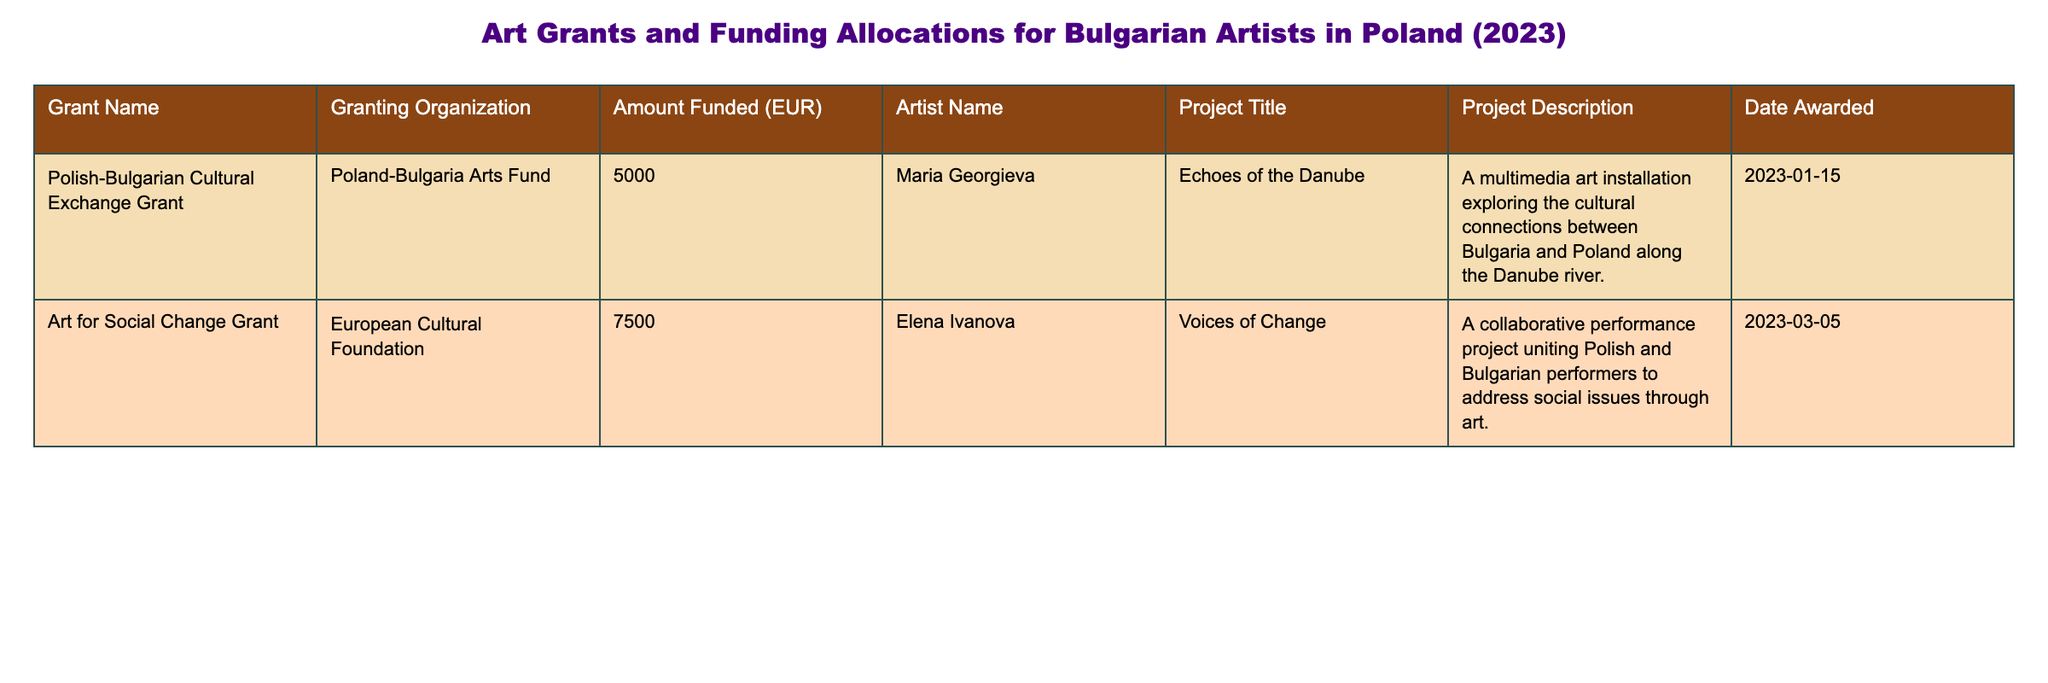What is the name of the grant awarded to Maria Georgieva? The table lists grants along with the names of the artists they were awarded to. According to the first row, the grant awarded to Maria Georgieva is the "Polish-Bulgarian Cultural Exchange Grant."
Answer: Polish-Bulgarian Cultural Exchange Grant How much funding was allocated to the project "Voices of Change"? In the second row of the table, the amount funded for the project "Voices of Change" is stated as 7500 EUR.
Answer: 7500 EUR Is there a grant supporting collaborative projects between Polish and Bulgarian artists? The table reveals information about various grants. The second row shows that the "Art for Social Change Grant" funds a collaborative performance project uniting Polish and Bulgarian performers, indicating that such a grant exists.
Answer: Yes What is the total amount funded to Bulgarian artists in Poland according to this table? To calculate the total amount funded, we sum the amounts from both rows: 5000 EUR (for "Echoes of the Danube") + 7500 EUR (for "Voices of Change") equals 12500 EUR. Thus, the total amount funded to Bulgarian artists is 12500 EUR.
Answer: 12500 EUR Which project explores the cultural connections between Bulgaria and Poland? By examining the project titles and descriptions, the first row of the table describes "Echoes of the Danube" as a multimedia art installation that explores cultural connections between Bulgaria and Poland along the Danube river.
Answer: Echoes of the Danube How many grants were awarded in total? The table lists two rows, each corresponding to one grant. Therefore, there are a total of two grants awarded to Bulgarian artists in Poland.
Answer: 2 Was the "Art for Social Change Grant" awarded before March 2023? Looking at the date awarded for the "Art for Social Change Grant," which is stated as March 5, 2023, we can determine that this grant was awarded in March 2023, which is the same month and not before.
Answer: No What is the project description for the grant received by Elena Ivanova? The table specifies the project description in the row corresponding to Elena Ivanova's grant. For the "Voices of Change," it states the description as a collaborative performance project addressing social issues through art.
Answer: A collaborative performance project uniting Polish and Bulgarian performers to address social issues through art 